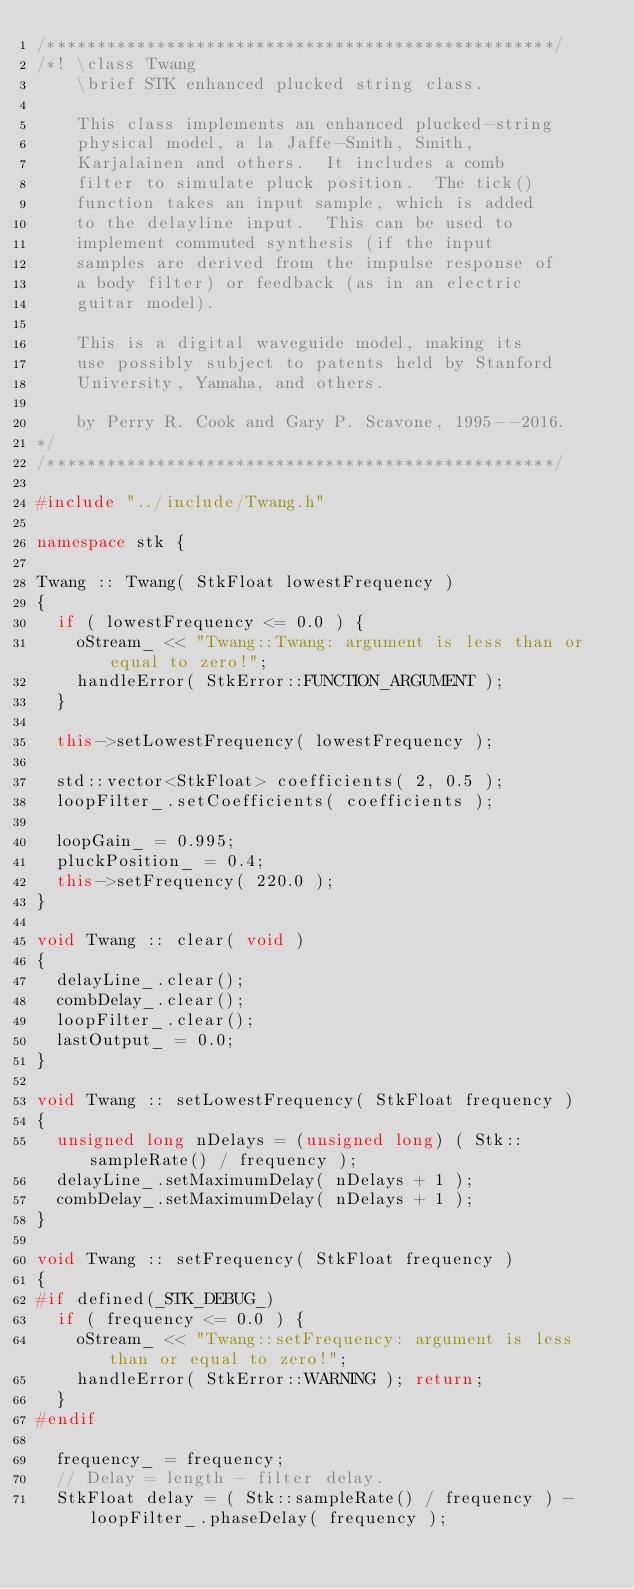<code> <loc_0><loc_0><loc_500><loc_500><_C++_>/***************************************************/
/*! \class Twang
    \brief STK enhanced plucked string class.

    This class implements an enhanced plucked-string
    physical model, a la Jaffe-Smith, Smith,
    Karjalainen and others.  It includes a comb
    filter to simulate pluck position.  The tick()
    function takes an input sample, which is added
    to the delayline input.  This can be used to
    implement commuted synthesis (if the input
    samples are derived from the impulse response of
    a body filter) or feedback (as in an electric
    guitar model).

    This is a digital waveguide model, making its
    use possibly subject to patents held by Stanford
    University, Yamaha, and others.

    by Perry R. Cook and Gary P. Scavone, 1995--2016.
*/
/***************************************************/

#include "../include/Twang.h"

namespace stk {

Twang :: Twang( StkFloat lowestFrequency )
{
  if ( lowestFrequency <= 0.0 ) {
    oStream_ << "Twang::Twang: argument is less than or equal to zero!";
    handleError( StkError::FUNCTION_ARGUMENT );
  }

  this->setLowestFrequency( lowestFrequency );

  std::vector<StkFloat> coefficients( 2, 0.5 );
  loopFilter_.setCoefficients( coefficients );

  loopGain_ = 0.995;
  pluckPosition_ = 0.4;
  this->setFrequency( 220.0 );
}

void Twang :: clear( void )
{
  delayLine_.clear();
  combDelay_.clear();
  loopFilter_.clear();
  lastOutput_ = 0.0;
}

void Twang :: setLowestFrequency( StkFloat frequency )
{
  unsigned long nDelays = (unsigned long) ( Stk::sampleRate() / frequency );
  delayLine_.setMaximumDelay( nDelays + 1 );
  combDelay_.setMaximumDelay( nDelays + 1 );
}

void Twang :: setFrequency( StkFloat frequency )
{
#if defined(_STK_DEBUG_)
  if ( frequency <= 0.0 ) {
    oStream_ << "Twang::setFrequency: argument is less than or equal to zero!";
    handleError( StkError::WARNING ); return;
  }
#endif

  frequency_ = frequency;
  // Delay = length - filter delay.
  StkFloat delay = ( Stk::sampleRate() / frequency ) - loopFilter_.phaseDelay( frequency );</code> 